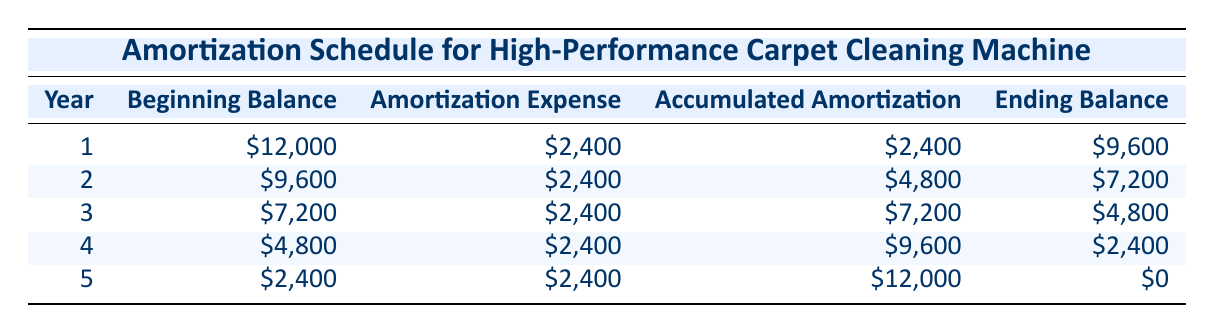What is the purchase price of the carpet cleaning machine? The purchase price is listed in the first row under the title "Amortization Schedule for High-Performance Carpet Cleaning Machine." The entry shows that the purchase price is 12000.
Answer: 12000 What is the amortization expense for year 3? The amortization expense for year 3 is available in the third row of the table, where it indicates the amortization expense as 2400.
Answer: 2400 What is the total accumulated amortization by the end of year 5? Looking at the last row of the table, the total accumulated amortization by the end of year 5 is noted as 12000.
Answer: 12000 Is the ending balance in year 4 equal to the beginning balance in year 5? In year 4, the ending balance is 2400, and in year 5, the beginning balance is also 2400, thus confirming they are equal.
Answer: Yes What is the average annual amortization expense over the 5 years? The annual amortization expense is consistent at 2400 for each of the 5 years. Therefore, since all expenses are the same, the average remains 2400.
Answer: 2400 By how much did the beginning balance decrease from year 1 to year 2? The beginning balance in year 1 is 12000 and in year 2 is 9600. The difference is calculated as 12000 - 9600, equating to 2400.
Answer: 2400 Which year showed the highest ending balance? Reviewing the ending balances from each year, we find year 1 had an ending balance of 9600, which is greater than any of the ending balances in subsequent years (7200, 4800, 2400, and 0).
Answer: Year 1 What was the total decline in the beginning balance from year 1 to year 5? The beginning balance decreased from 12000 in year 1 to 2400 in year 5. The total decline is calculated as 12000 - 2400, which equals 9600.
Answer: 9600 Is the salvage value reflected anywhere in the amortization table? The amortization table provided does not include a specific row for salvage value; hence, the answer is no, it is not reflected in the table.
Answer: No 